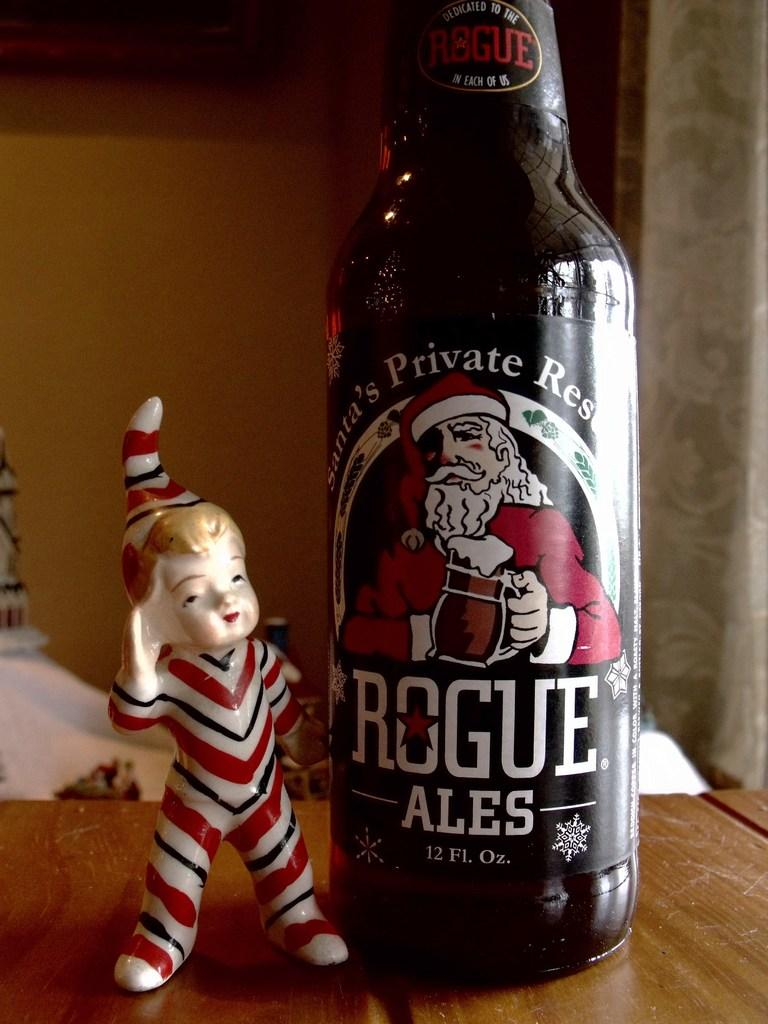<image>
Create a compact narrative representing the image presented. A bottle of Rogue Ales sits next to a small elf statue. 